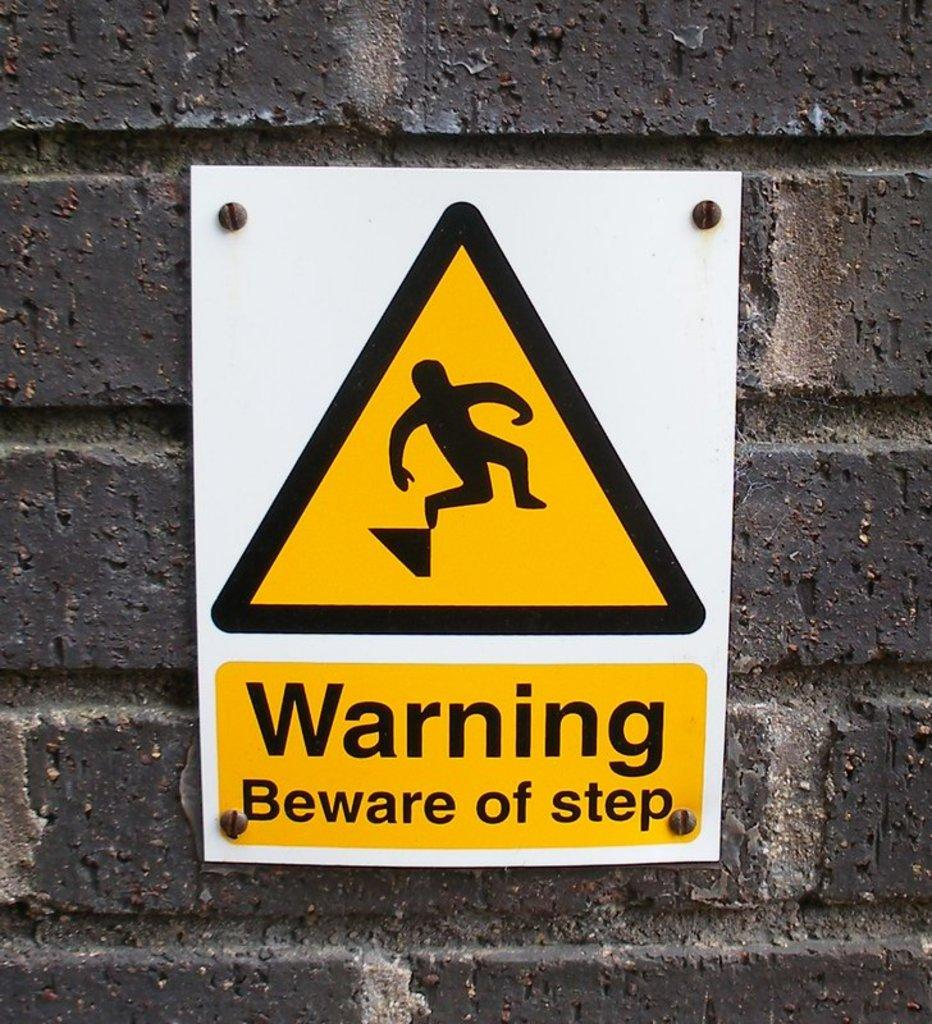<image>
Provide a brief description of the given image. A warning sign that says to beware of step. 